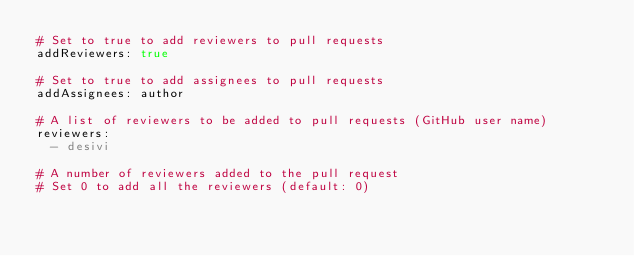Convert code to text. <code><loc_0><loc_0><loc_500><loc_500><_YAML_># Set to true to add reviewers to pull requests
addReviewers: true

# Set to true to add assignees to pull requests
addAssignees: author

# A list of reviewers to be added to pull requests (GitHub user name)
reviewers:
  - desivi

# A number of reviewers added to the pull request
# Set 0 to add all the reviewers (default: 0)</code> 